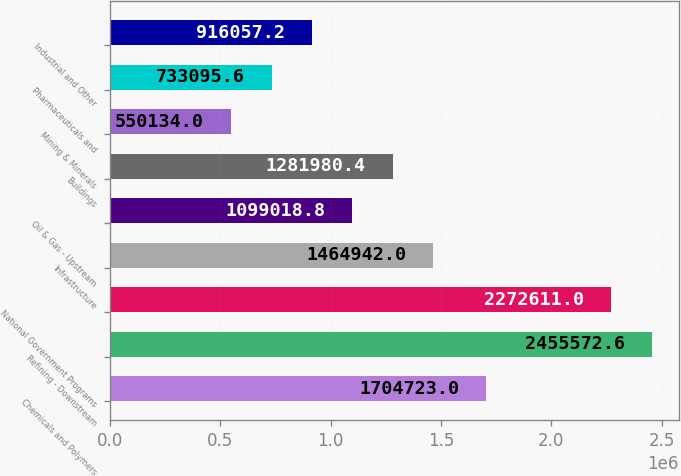<chart> <loc_0><loc_0><loc_500><loc_500><bar_chart><fcel>Chemicals and Polymers<fcel>Refining - Downstream<fcel>National Government Programs<fcel>Infrastructure<fcel>Oil & Gas - Upstream<fcel>Buildings<fcel>Mining & Minerals<fcel>Pharmaceuticals and<fcel>Industrial and Other<nl><fcel>1.70472e+06<fcel>2.45557e+06<fcel>2.27261e+06<fcel>1.46494e+06<fcel>1.09902e+06<fcel>1.28198e+06<fcel>550134<fcel>733096<fcel>916057<nl></chart> 